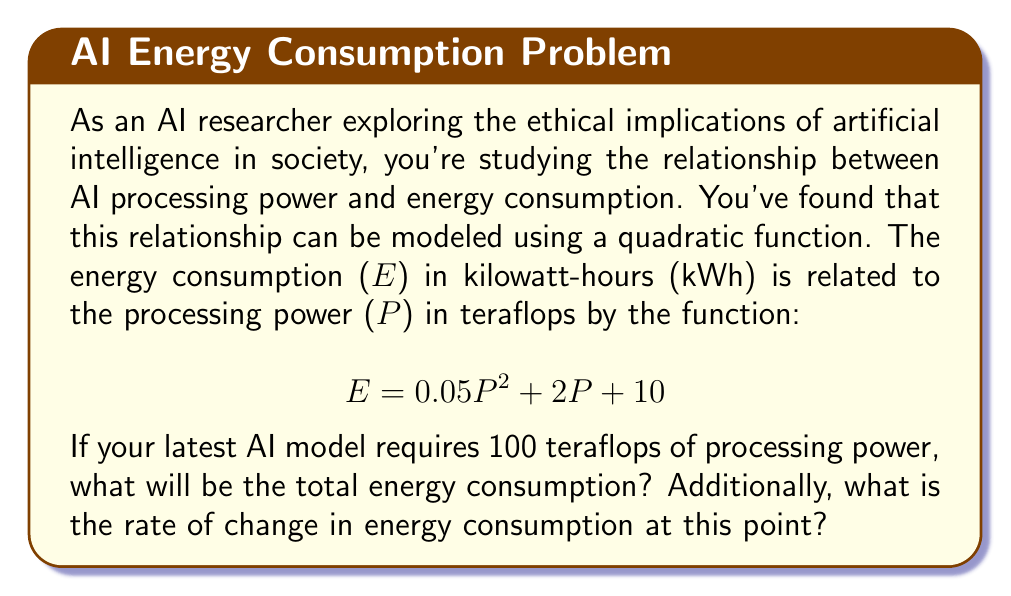Could you help me with this problem? To solve this problem, we need to follow these steps:

1. Calculate the energy consumption:
   Substitute P = 100 into the given quadratic function:
   $$ E = 0.05(100)^2 + 2(100) + 10 $$
   $$ E = 0.05(10000) + 200 + 10 $$
   $$ E = 500 + 200 + 10 = 710 \text{ kWh} $$

2. Find the rate of change in energy consumption:
   The rate of change is given by the derivative of the function with respect to P:
   $$ \frac{dE}{dP} = 0.1P + 2 $$
   
   At P = 100:
   $$ \frac{dE}{dP} = 0.1(100) + 2 = 10 + 2 = 12 \text{ kWh/teraflop} $$

This rate of change indicates that for each additional teraflop of processing power at this point, the energy consumption would increase by approximately 12 kWh.
Answer: The total energy consumption is 710 kWh, and the rate of change in energy consumption at 100 teraflops is 12 kWh/teraflop. 